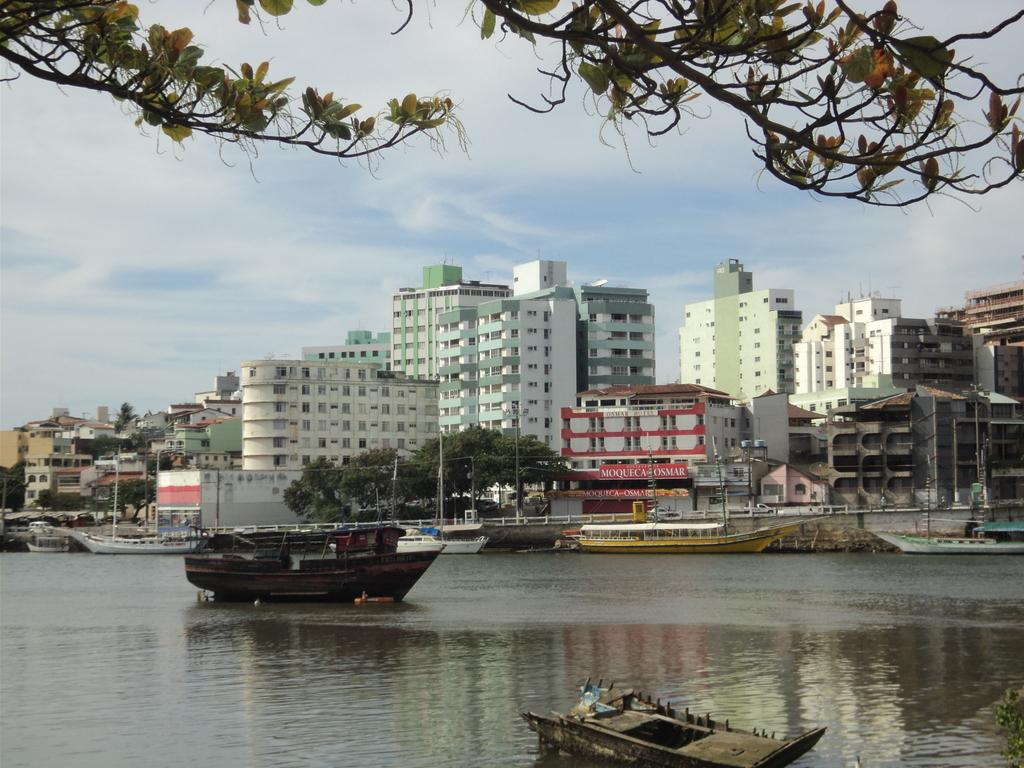What is on the water in the image? There are boats on the water in the image. What else can be seen in the image besides the boats? There are buildings and trees visible in the image. What is visible in the background of the image? The sky is visible in the background of the image. What degree does the porter have in the image? There is no porter present in the image, so it is not possible to determine their degree. What idea is being conveyed by the trees in the image? The trees in the image are not conveying any specific idea; they are simply part of the natural landscape. 